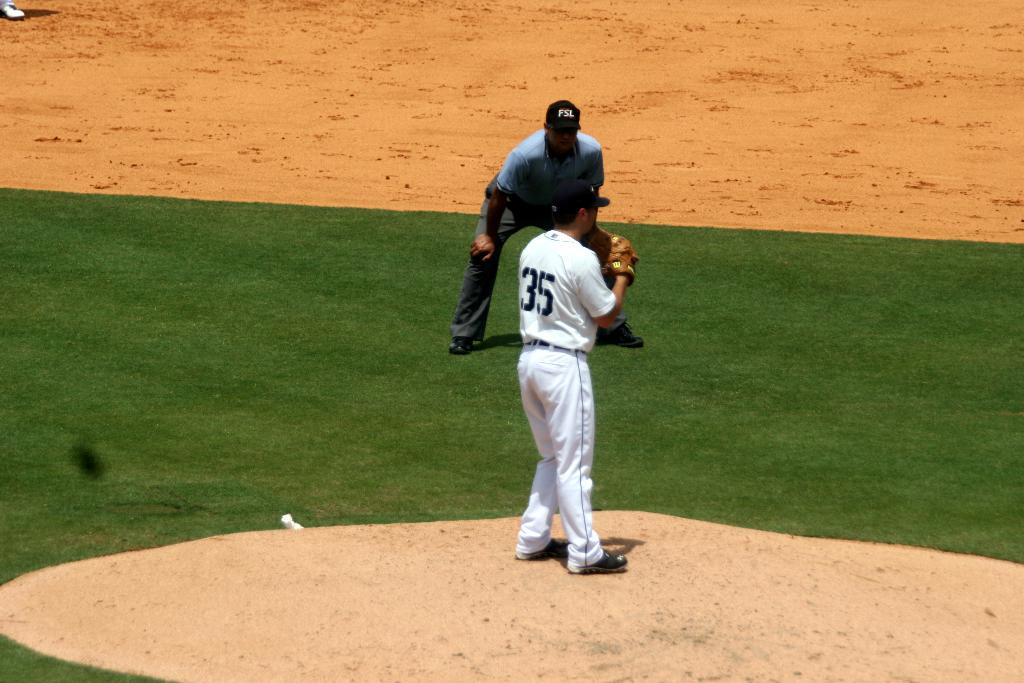<image>
Offer a succinct explanation of the picture presented. Man wearing a white jersey which says number 35. 